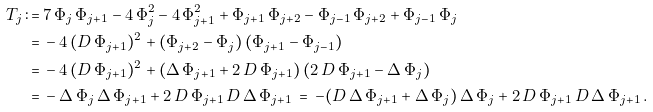Convert formula to latex. <formula><loc_0><loc_0><loc_500><loc_500>T _ { j } \, \colon = & \, 7 \, \Phi _ { j } \, \Phi _ { j + 1 } - 4 \, \Phi _ { j } ^ { 2 } - 4 \, \Phi _ { j + 1 } ^ { 2 } + \Phi _ { j + 1 } \, \Phi _ { j + 2 } - \Phi _ { j - 1 } \, \Phi _ { j + 2 } + \Phi _ { j - 1 } \, \Phi _ { j } \\ = & \, - 4 \, ( D \, \Phi _ { j + 1 } ) ^ { 2 } + ( \Phi _ { j + 2 } - \Phi _ { j } ) \, ( \Phi _ { j + 1 } - \Phi _ { j - 1 } ) \\ = & \, - 4 \, ( D \, \Phi _ { j + 1 } ) ^ { 2 } + ( \Delta \, \Phi _ { j + 1 } + 2 \, D \, \Phi _ { j + 1 } ) \, ( 2 \, D \, \Phi _ { j + 1 } - \Delta \, \Phi _ { j } ) \\ = & \, - \Delta \, \Phi _ { j } \, \Delta \, \Phi _ { j + 1 } + 2 \, D \, \Phi _ { j + 1 } \, D \, \Delta \, \Phi _ { j + 1 } \, = \, - ( D \, \Delta \, \Phi _ { j + 1 } + \Delta \, \Phi _ { j } ) \, \Delta \, \Phi _ { j } + 2 \, D \, \Phi _ { j + 1 } \, D \, \Delta \, \Phi _ { j + 1 } \, .</formula> 